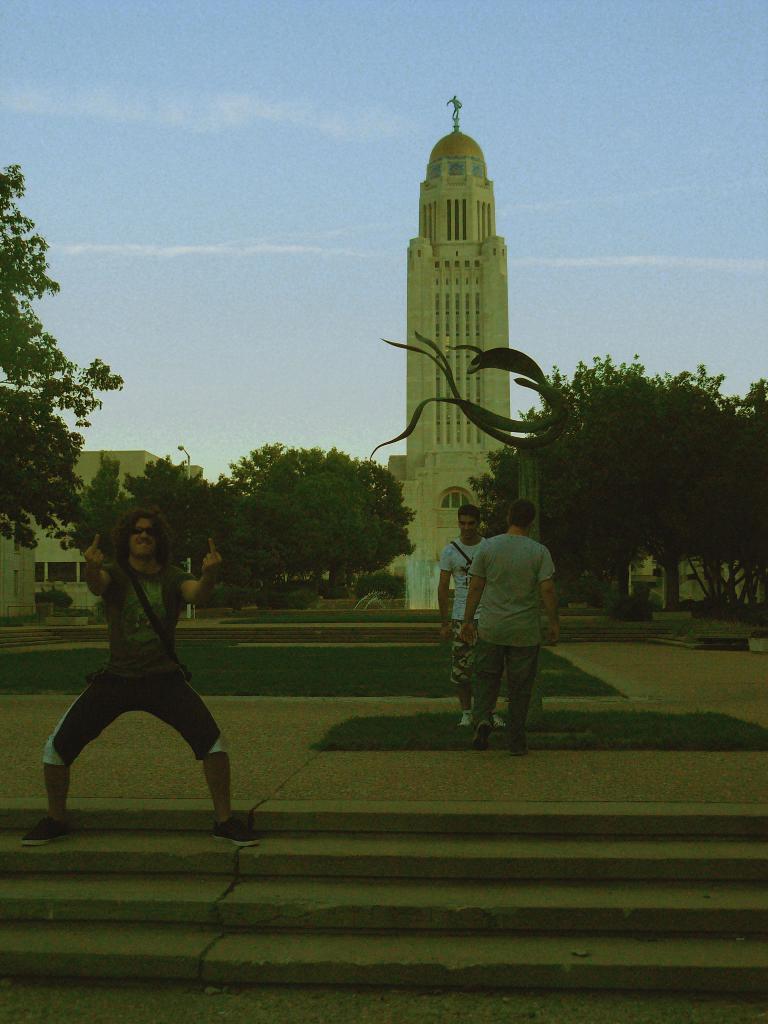Could you give a brief overview of what you see in this image? In this image there are trees, buildings and there is a person on the left corner. There are trees and buildings on the right corner. We can see steps, there are people standing, there is an object in the foreground. There are trees and there is a building in the background. And there is sky at the top. 